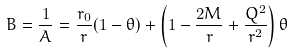<formula> <loc_0><loc_0><loc_500><loc_500>B = \frac { 1 } { A } = \frac { r _ { 0 } } { r } ( 1 - \theta ) + \left ( 1 - \frac { 2 M } { r } + \frac { Q ^ { 2 } } { r ^ { 2 } } \right ) \theta</formula> 